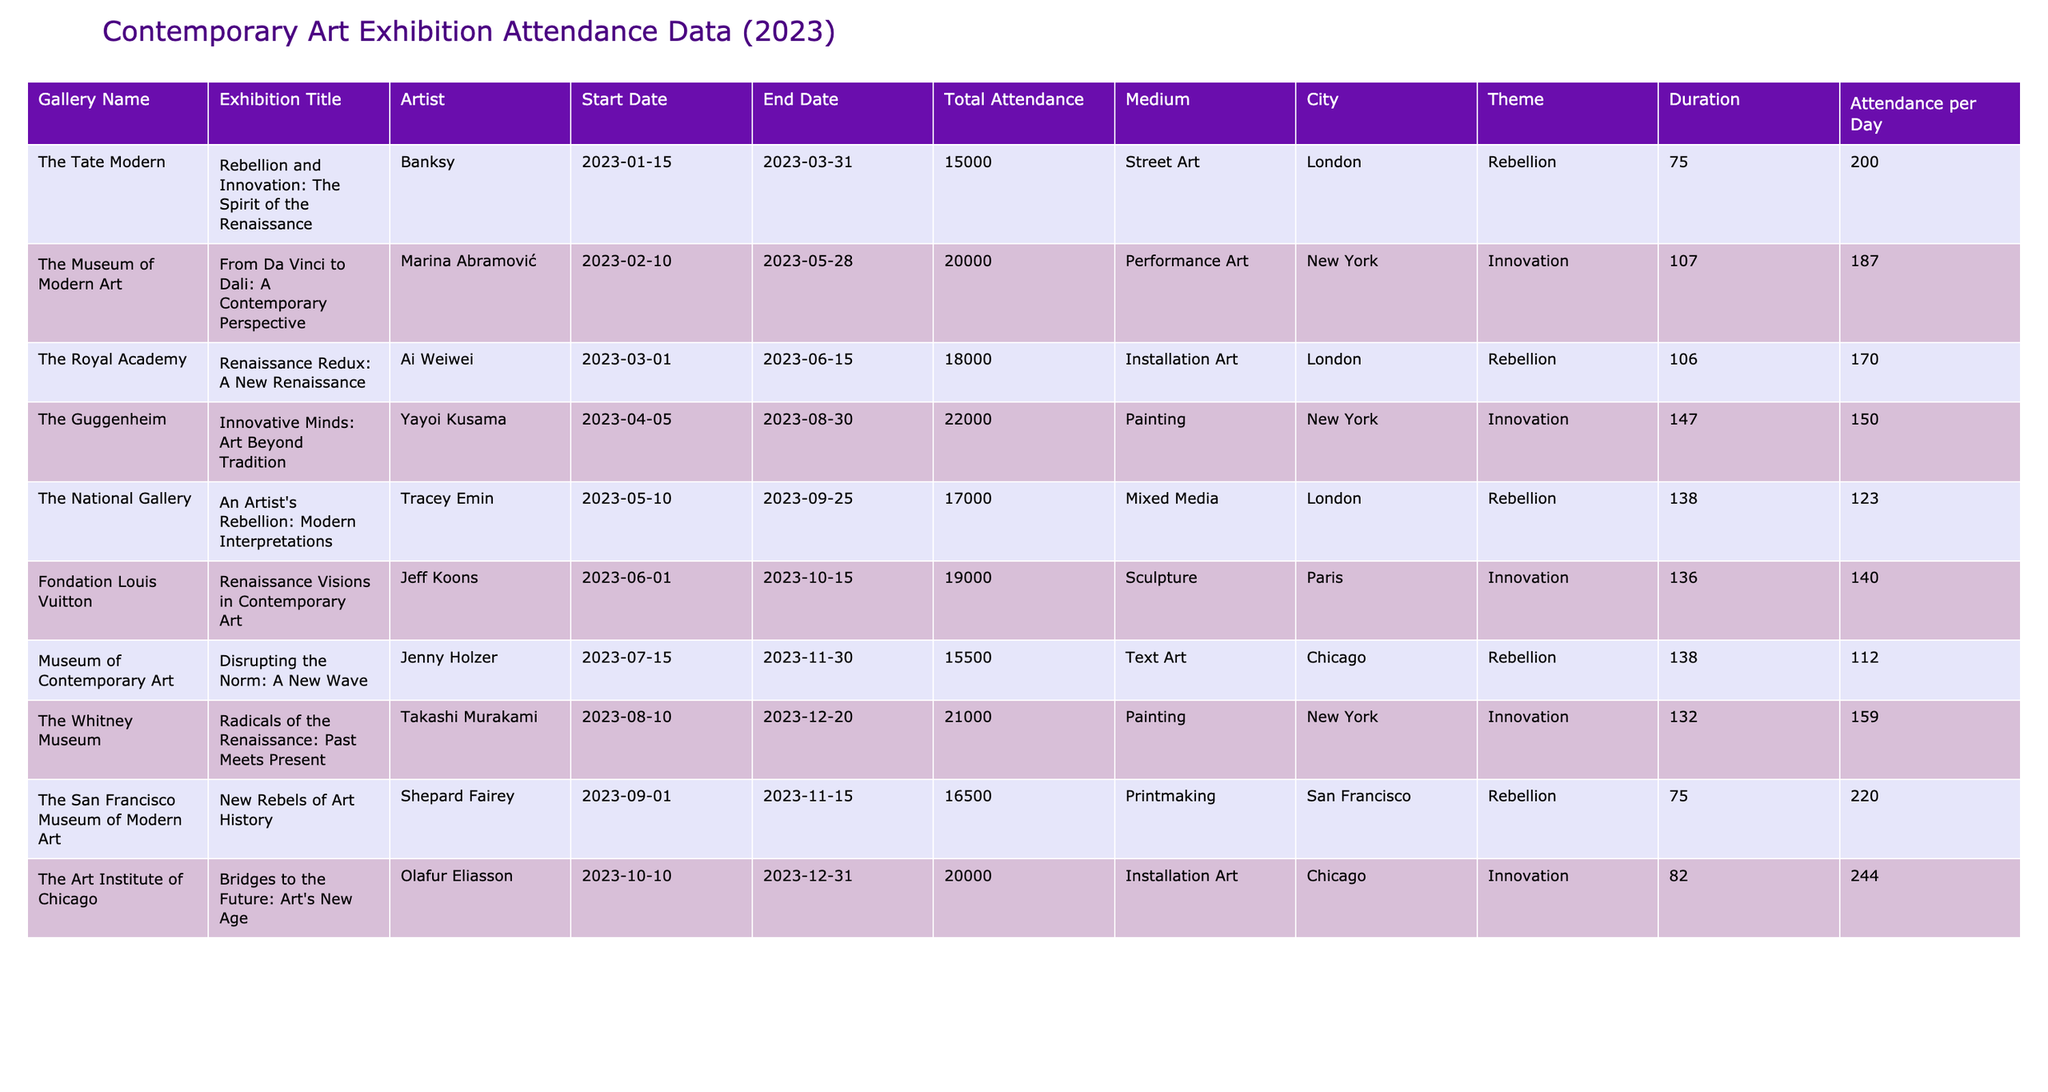What is the total attendance of the exhibition "Innovative Minds: Art Beyond Tradition"? Referring to the table, the total attendance for the exhibition titled "Innovative Minds: Art Beyond Tradition" at The Guggenheim is found in the corresponding row, which shows 22,000 attendees.
Answer: 22000 Which artist had the highest total attendance for their exhibition in 2023? By examining the 'Total Attendance' column, the highest value is 22,000, which corresponds to the artist Yayoi Kusama for the exhibition "Innovative Minds: Art Beyond Tradition."
Answer: Yayoi Kusama What is the average attendance per day for the exhibition "Renaissance Redux: A New Renaissance"? The 'Duration' for this exhibition is (June 15 - March 1) = 107 days. The total attendance of this exhibition is 18,000. Therefore, the average attendance per day is 18,000 / 107 ≈ 168.
Answer: 168 How many exhibitions had a theme of "Rebellion"? Counting the rows in the table where the theme is "Rebellion," there are 5 exhibitions: "Rebellion and Innovation," "Renaissance Redux," "An Artist's Rebellion," "Disrupting the Norm," and "New Rebels of Art History."
Answer: 5 What is the total attendance of all exhibitions themed "Innovation"? The total attendance for the exhibitions with an "Innovation" theme is the sum of their individual attendances: 20,000 (from MoMA) + 22,000 (from Guggenheim) + 19,000 (from Fondation Louis Vuitton) + 21,000 (from Whitney Museum) + 20,000 (from Art Institute of Chicago) = 102,000.
Answer: 102000 Which city had the most exhibitions with a theme of "Innovation"? If we look at the table, New York has 3 exhibitions themed "Innovation" - specifically at MoMA, Guggenheim and Whitney Museum, while other cities have 1 or 2. Thus, New York has the most exhibitions in that category.
Answer: New York What is the difference in total attendance between the exhibition "From Da Vinci to Dali" and "An Artist's Rebellion"? The total attendance for "From Da Vinci to Dali" is 20,000 and for "An Artist's Rebellion" is 17,000. Therefore, the difference is 20,000 - 17,000 = 3,000.
Answer: 3000 Is the total attendance for the exhibition "Disrupting the Norm" higher than that for "Bridges to the Future"? Checking the table, "Disrupting the Norm" has a total attendance of 15,500, while "Bridges to the Future" has 20,000. Hence, 15,500 is not higher than 20,000.
Answer: No What is the total attendance for all exhibitions in London? Summing the attendance for exhibitions in London: 15,000 (Tate Modern) + 18,000 (Royal Academy) + 17,000 (National Gallery) = 50,000.
Answer: 50000 For which exhibition was the attendance per day the highest among those appearing in the table? Calculating the 'Attendance per Day' for each exhibition, the highest value is found for "Innovative Minds: Art Beyond Tradition" with an average of 185 attendees per day.
Answer: 185 